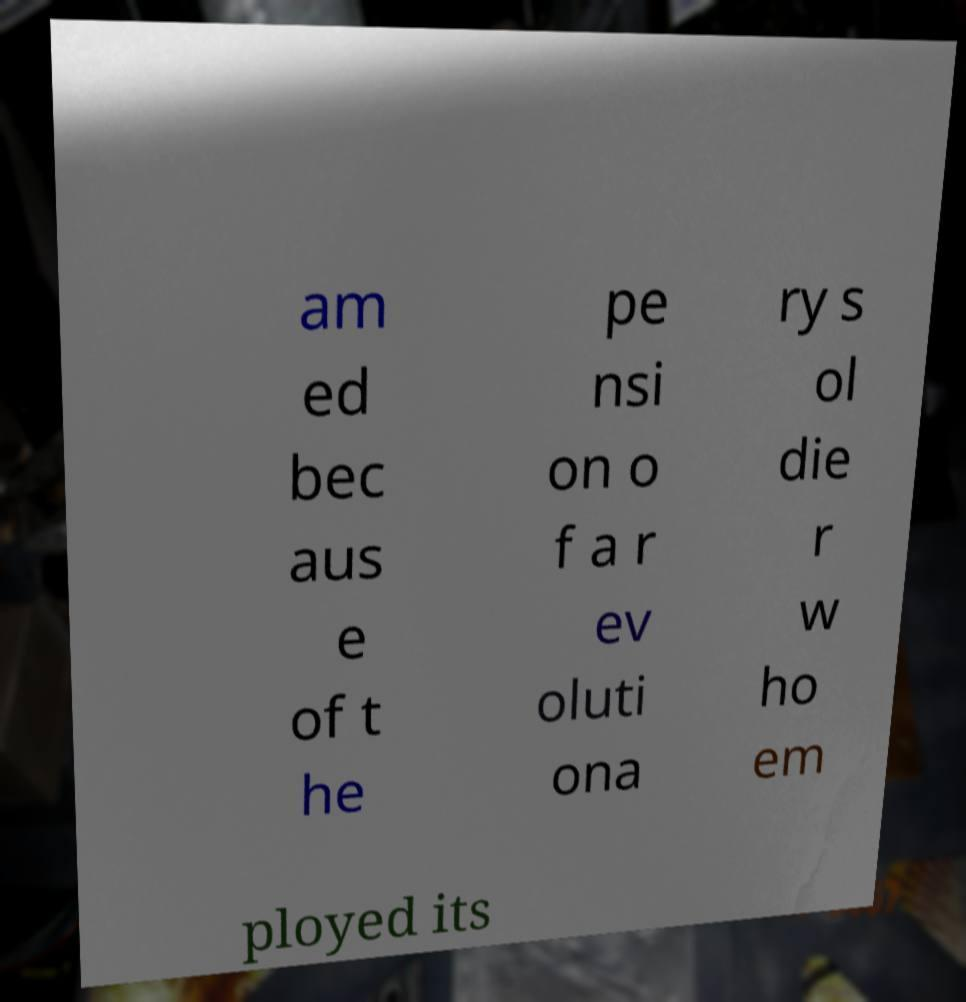What messages or text are displayed in this image? I need them in a readable, typed format. am ed bec aus e of t he pe nsi on o f a r ev oluti ona ry s ol die r w ho em ployed its 